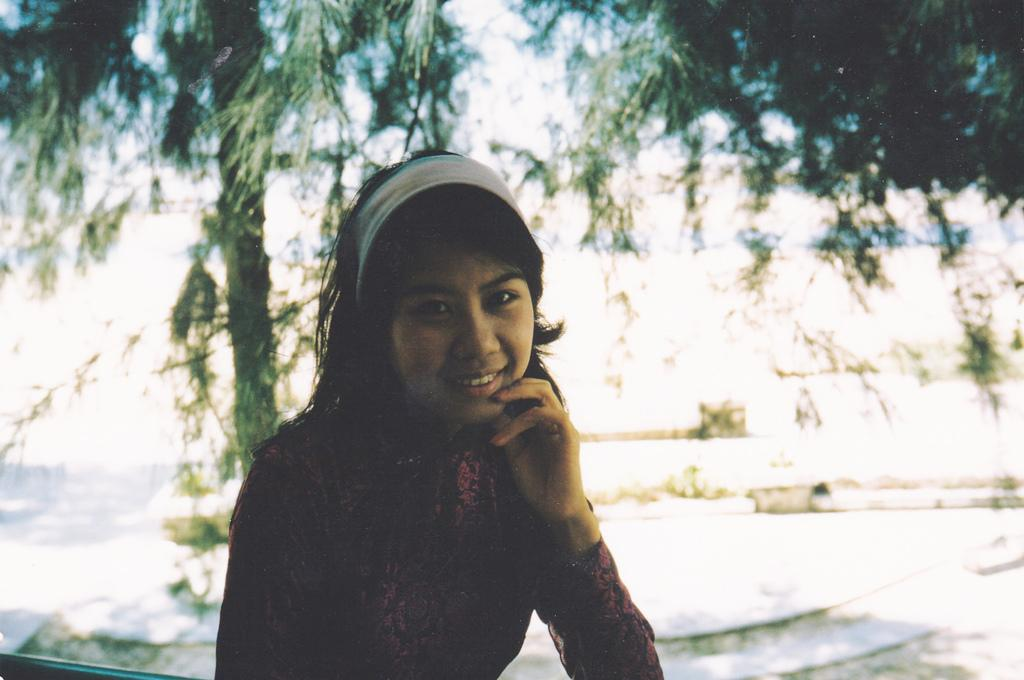Who is the main subject in the image? There is a girl in the center of the image. What is the girl doing in the image? The girl is sitting in the image. What is the girl's facial expression in the image? The girl is smiling in the image. What is the girl wearing on her head in the image? The girl is wearing a headband in the image. What can be seen in the background of the image? There are trees in the background of the image. What type of throne is the girl sitting on in the image? There is no throne present in the image; the girl is sitting on a regular surface, such as a bench or the ground. 